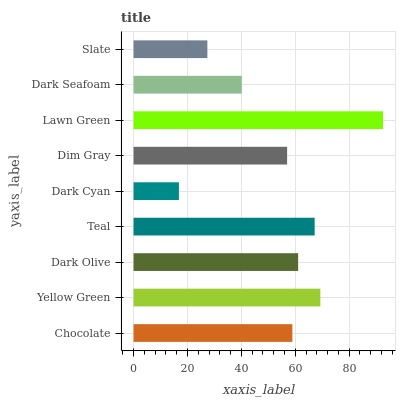Is Dark Cyan the minimum?
Answer yes or no. Yes. Is Lawn Green the maximum?
Answer yes or no. Yes. Is Yellow Green the minimum?
Answer yes or no. No. Is Yellow Green the maximum?
Answer yes or no. No. Is Yellow Green greater than Chocolate?
Answer yes or no. Yes. Is Chocolate less than Yellow Green?
Answer yes or no. Yes. Is Chocolate greater than Yellow Green?
Answer yes or no. No. Is Yellow Green less than Chocolate?
Answer yes or no. No. Is Chocolate the high median?
Answer yes or no. Yes. Is Chocolate the low median?
Answer yes or no. Yes. Is Slate the high median?
Answer yes or no. No. Is Dim Gray the low median?
Answer yes or no. No. 